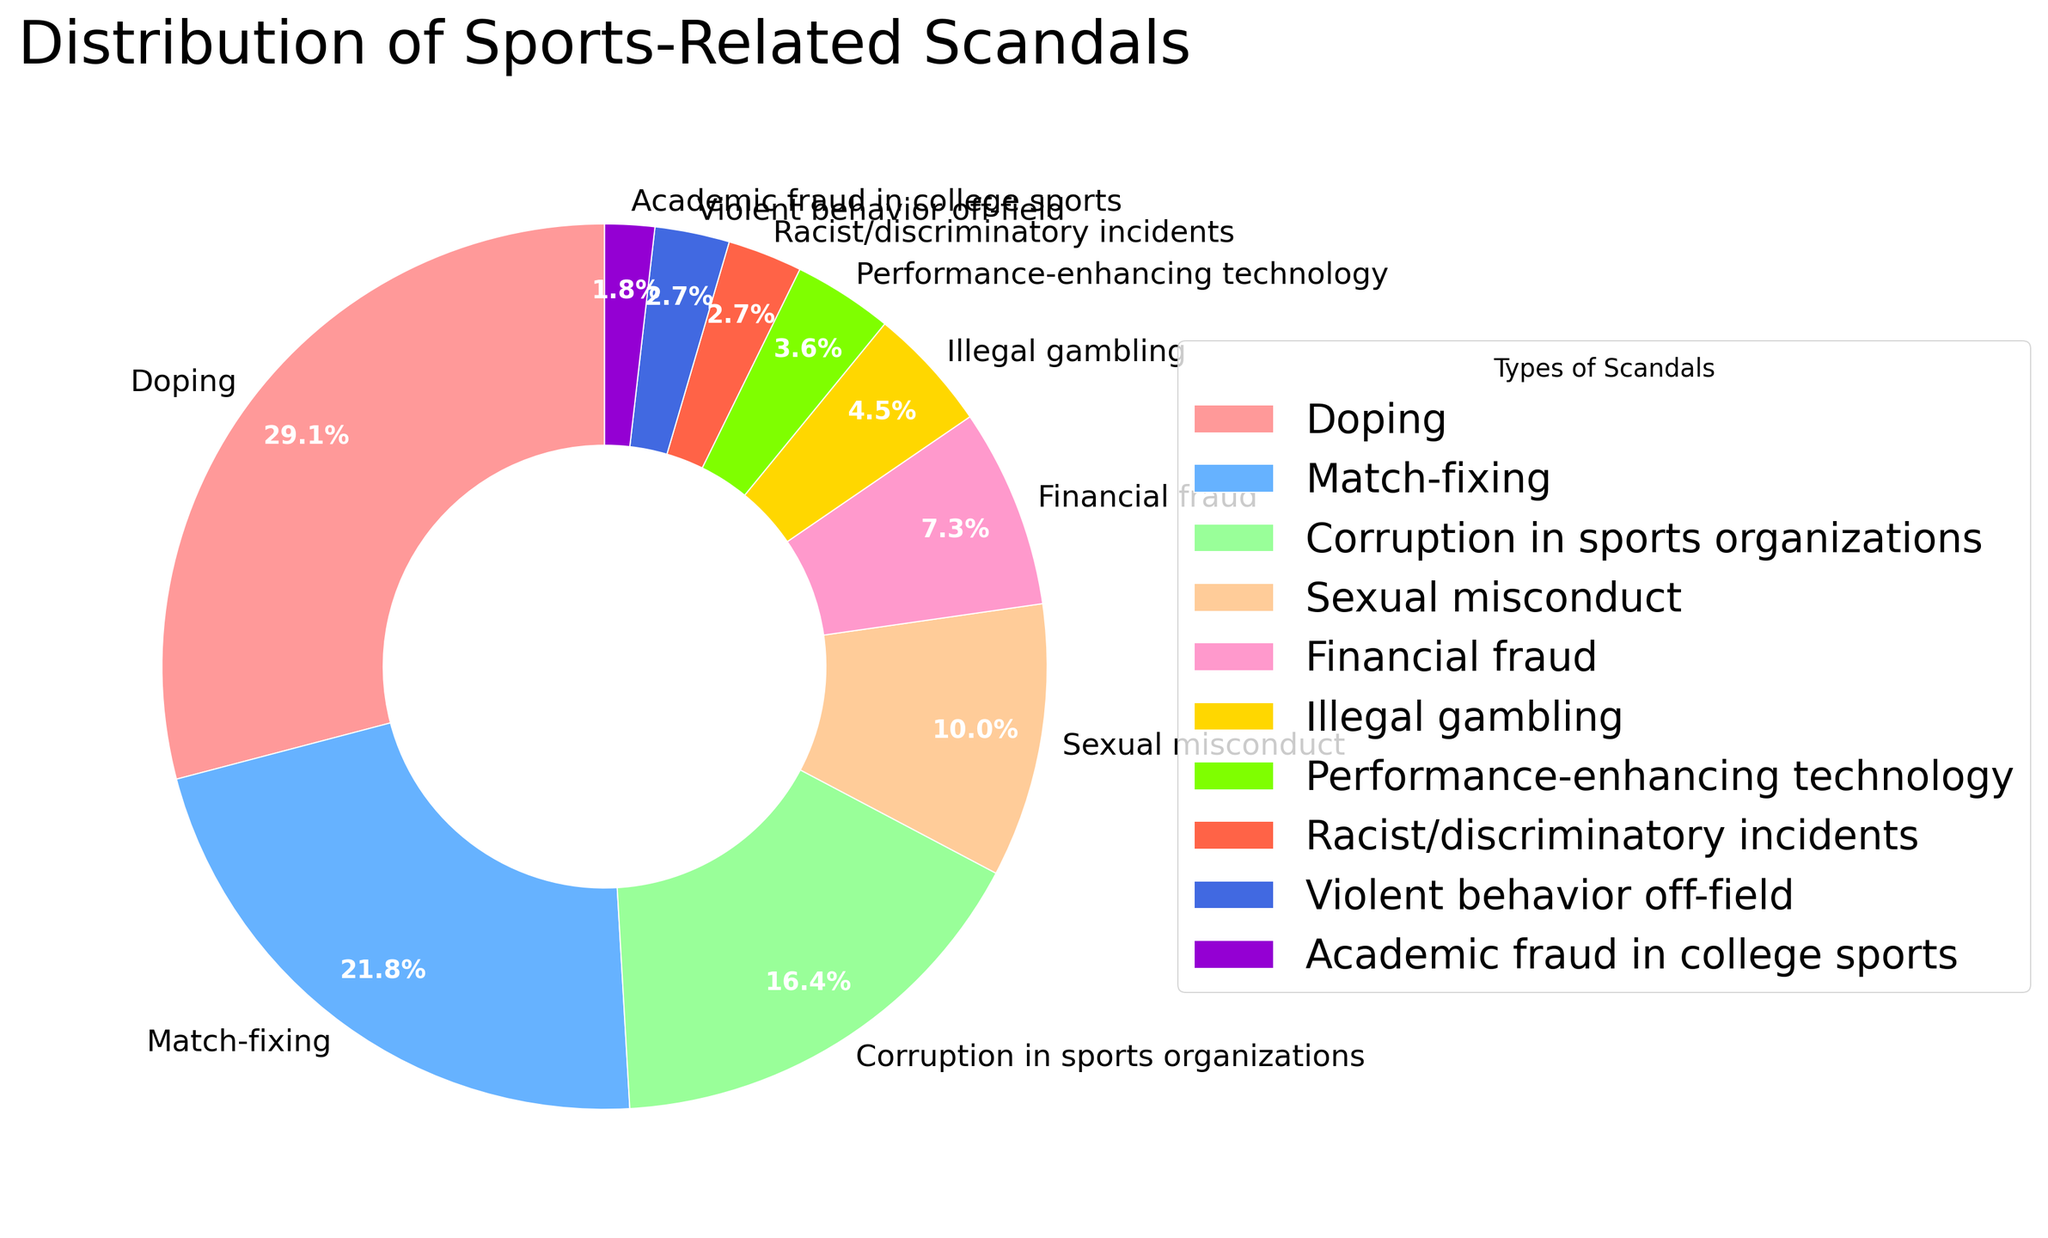Which type of scandal has the highest percentage? By looking at the pie chart, the largest slice represents doping. The label and percentage for doping confirm it is the highest.
Answer: Doping How much more common is doping compared to illegal gambling? The pie chart shows doping at 32% and illegal gambling at 5%. The difference between these percentages is 32% - 5% = 27%.
Answer: 27% What is the combined percentage of doping and match-fixing scandals? The percentages for doping and match-fixing are 32% and 24%, respectively. Adding these gives 32% + 24% = 56%.
Answer: 56% Which scandal types are represented by the smallest slices? The smallest slices in the pie chart represent performance-enhancing technology, racist/discriminatory incidents, violent behavior off-field, and academic fraud in college sports, each with percentages of 4%, 3%, 3%, and 2%, respectively.
Answer: Performance-enhancing technology, racist/discriminatory incidents, violent behavior off-field, academic fraud in college sports Is the percentage of corruption in sports organizations higher or lower than financial fraud? The pie chart shows corruption in sports organizations at 18% and financial fraud at 8%. Since 18% > 8%, corruption in sports organizations is higher.
Answer: Higher What is the difference in percentage between sexual misconduct and financial fraud? From the pie chart, sexual misconduct is at 11% and financial fraud is at 8%. The difference is 11% - 8% = 3%.
Answer: 3% How does the percentage of match-fixing compare to the combined percentage of violent behavior off-field and academic fraud in college sports? Match-fixing is 24%. Violent behavior off-field and academic fraud in college sports combined are 3% + 2% = 5%. Since 24% > 5%, match-fixing is higher.
Answer: Higher What percentage of scandals are related to either financial fraud or illegal gambling? The percentages for financial fraud and illegal gambling are 8% and 5%, respectively. Adding these percentages gives 8% + 5% = 13%.
Answer: 13% Which type of scandal appears in the most vivid color slice (red)? By observing the visual attributes of the pie chart, the most vivid color slice (red) is allocated to doping.
Answer: Doping 